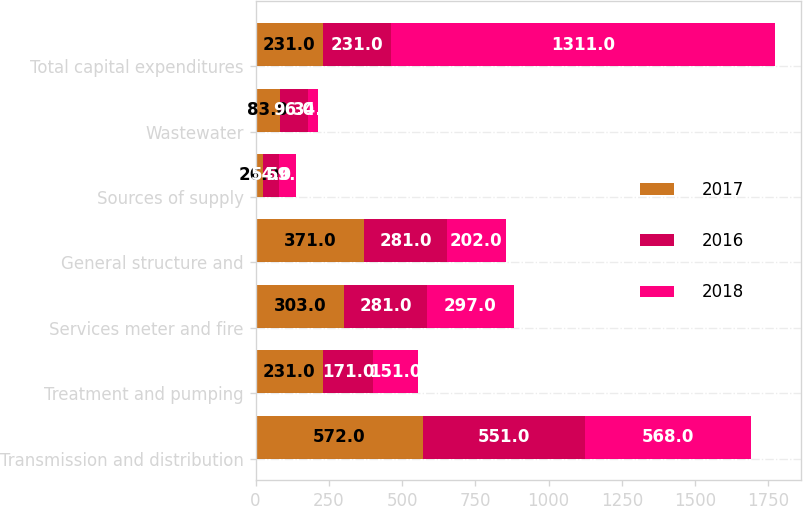Convert chart to OTSL. <chart><loc_0><loc_0><loc_500><loc_500><stacked_bar_chart><ecel><fcel>Transmission and distribution<fcel>Treatment and pumping<fcel>Services meter and fire<fcel>General structure and<fcel>Sources of supply<fcel>Wastewater<fcel>Total capital expenditures<nl><fcel>2017<fcel>572<fcel>231<fcel>303<fcel>371<fcel>26<fcel>83<fcel>231<nl><fcel>2016<fcel>551<fcel>171<fcel>281<fcel>281<fcel>54<fcel>96<fcel>231<nl><fcel>2018<fcel>568<fcel>151<fcel>297<fcel>202<fcel>59<fcel>34<fcel>1311<nl></chart> 